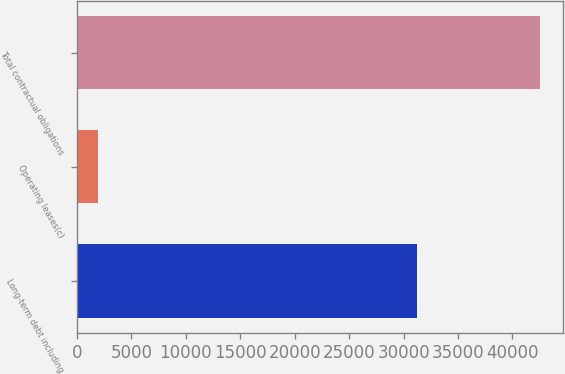<chart> <loc_0><loc_0><loc_500><loc_500><bar_chart><fcel>Long-term debt including<fcel>Operating leases(c)<fcel>Total contractual obligations<nl><fcel>31204<fcel>1951<fcel>42535<nl></chart> 